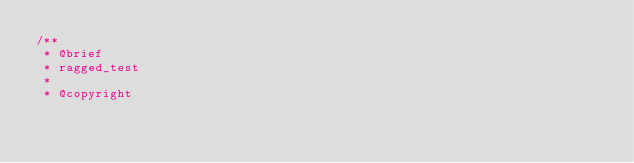Convert code to text. <code><loc_0><loc_0><loc_500><loc_500><_Cuda_>/**
 * @brief
 * ragged_test
 *
 * @copyright</code> 